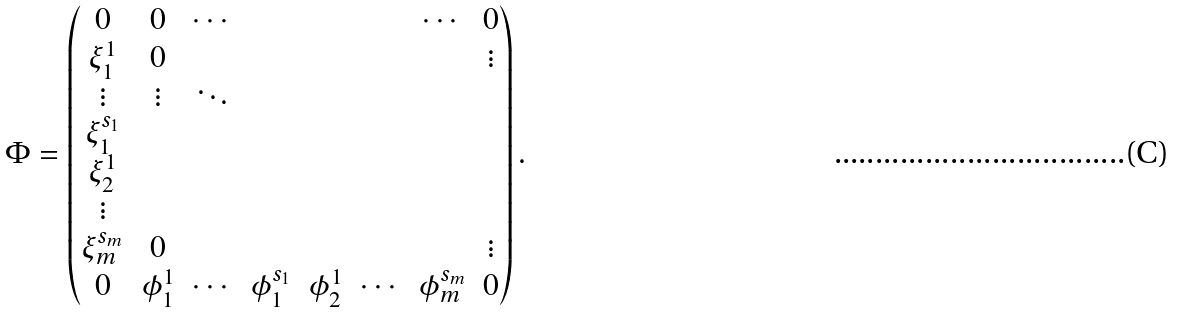<formula> <loc_0><loc_0><loc_500><loc_500>\Phi = \left ( \begin{matrix} 0 & 0 & \cdots & & & & \cdots & 0 \\ \xi ^ { 1 } _ { 1 } & 0 & & & & & & \vdots \\ \vdots & \vdots & \ddots & & & & & \\ \xi ^ { s _ { 1 } } _ { 1 } & & & & & & & \\ \xi ^ { 1 } _ { 2 } & & & & & & & \\ \vdots & & & & & & & \\ \xi _ { m } ^ { s _ { m } } & 0 & & & & & & \vdots \\ 0 & \phi ^ { 1 } _ { 1 } & \cdots & \phi _ { 1 } ^ { s _ { 1 } } & \phi ^ { 1 } _ { 2 } & \cdots & \phi _ { m } ^ { s _ { m } } & 0 \\ \end{matrix} \right ) .</formula> 